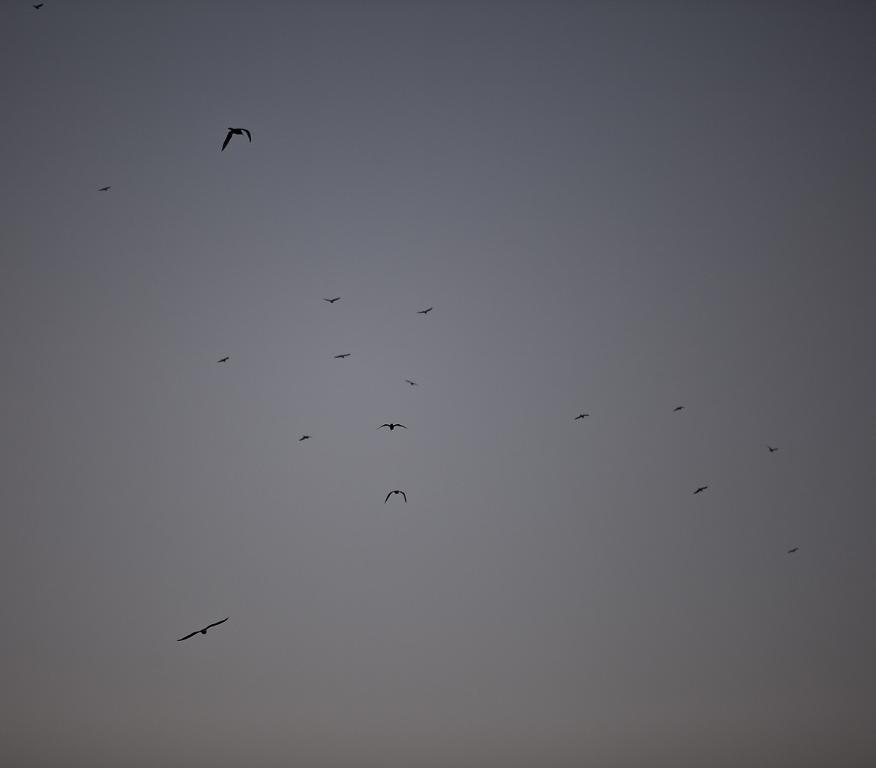What type of animals can be seen in the image? Birds can be seen in the image. What are the birds doing in the image? The birds are flying in the sky. Where is the person standing in the image? There is no person present in the image; it only features birds flying in the sky. What type of bomb can be seen in the image? There is no bomb present in the image; it only features birds flying in the sky. 